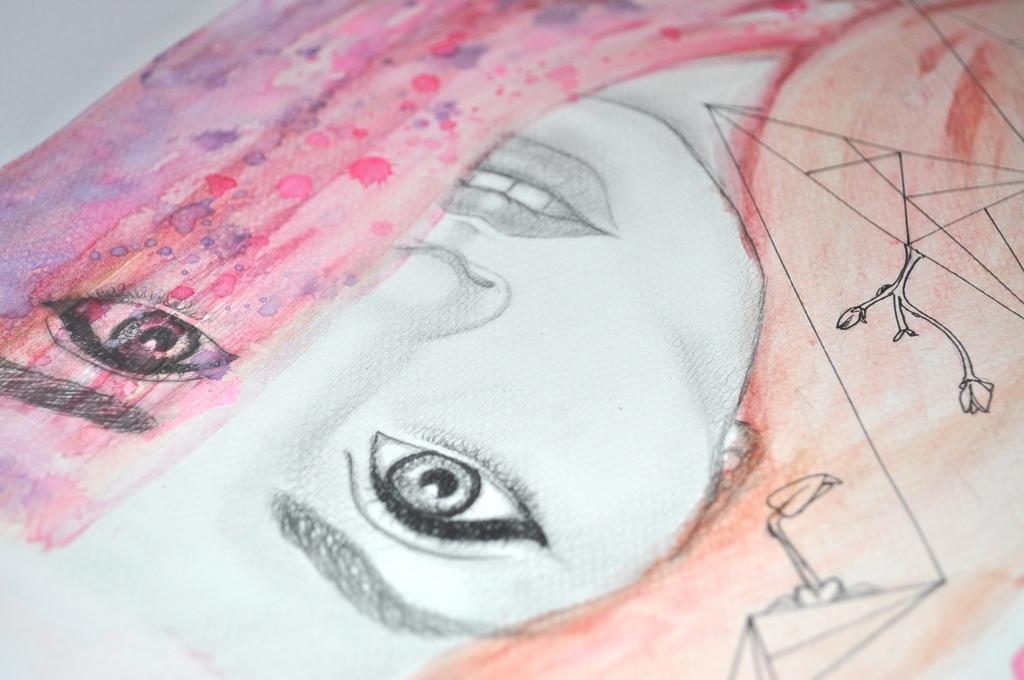Describe this image in one or two sentences. In this picture, there is a sketch of a woman with different colors. 